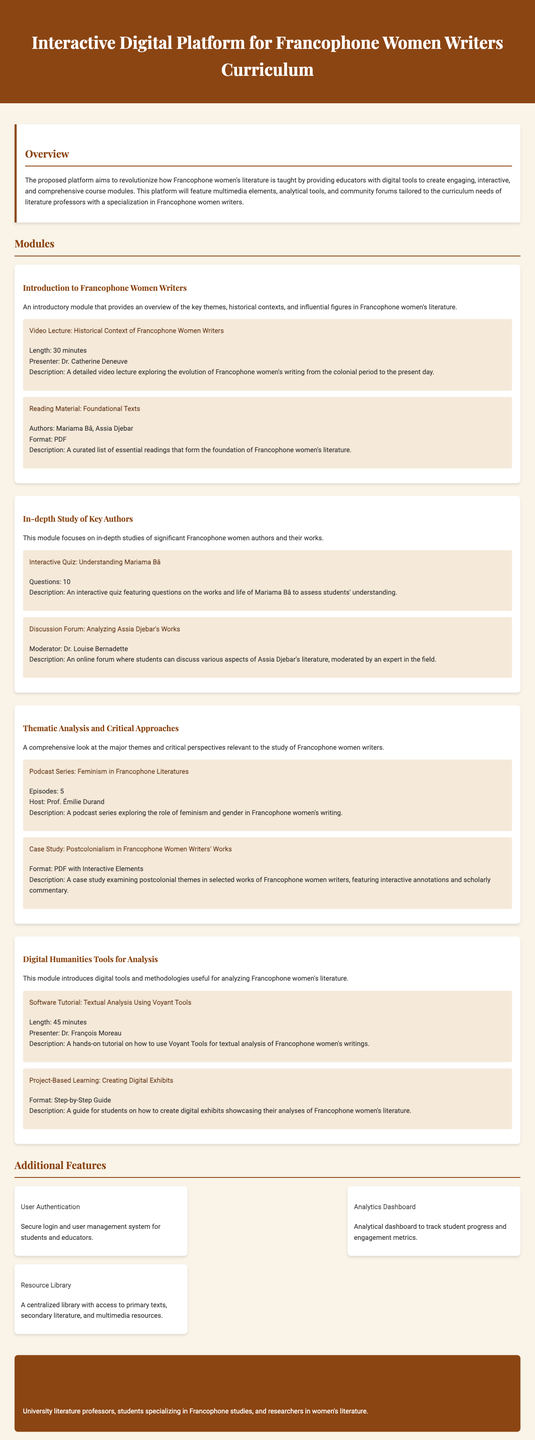what is the length of the video lecture on the historical context of Francophone women writers? The length of the video lecture is stated in the document as 30 minutes.
Answer: 30 minutes who is the presenter of the video lecture? The document mentions that Dr. Catherine Deneuve is the presenter of the video lecture.
Answer: Dr. Catherine Deneuve how many episodes are in the podcast series? The number of episodes in the podcast series is provided as 5.
Answer: 5 what is one of the functionalities of the analytics dashboard? The analytics dashboard is said to track student progress and engagement metrics.
Answer: Track student progress and engagement metrics name one of the authors included in the reading material for foundational texts. The document lists Mariama Bâ and Assia Djebar as authors in the reading material.
Answer: Mariama Bâ why is the platform targeting university literature professors? University literature professors are targeted because they specialize in teaching Francophone women's literature, necessitating digital tools for interactive teaching.
Answer: They specialize in teaching Francophone women's literature what type of resource will be provided in the resource library? The resource library will provide access to primary texts, secondary literature, and multimedia resources.
Answer: Primary texts, secondary literature, and multimedia resources 